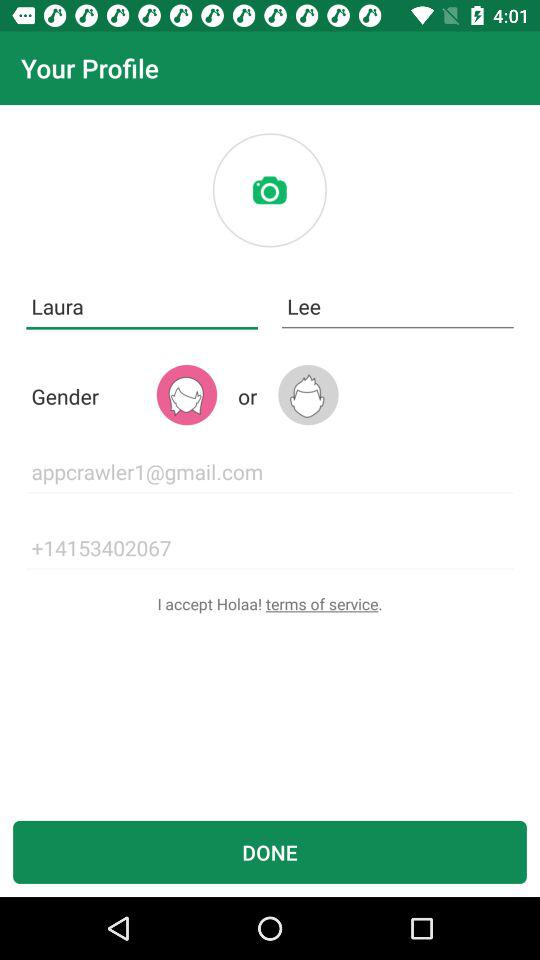What is the phone number? The phone number is +14153402067. 